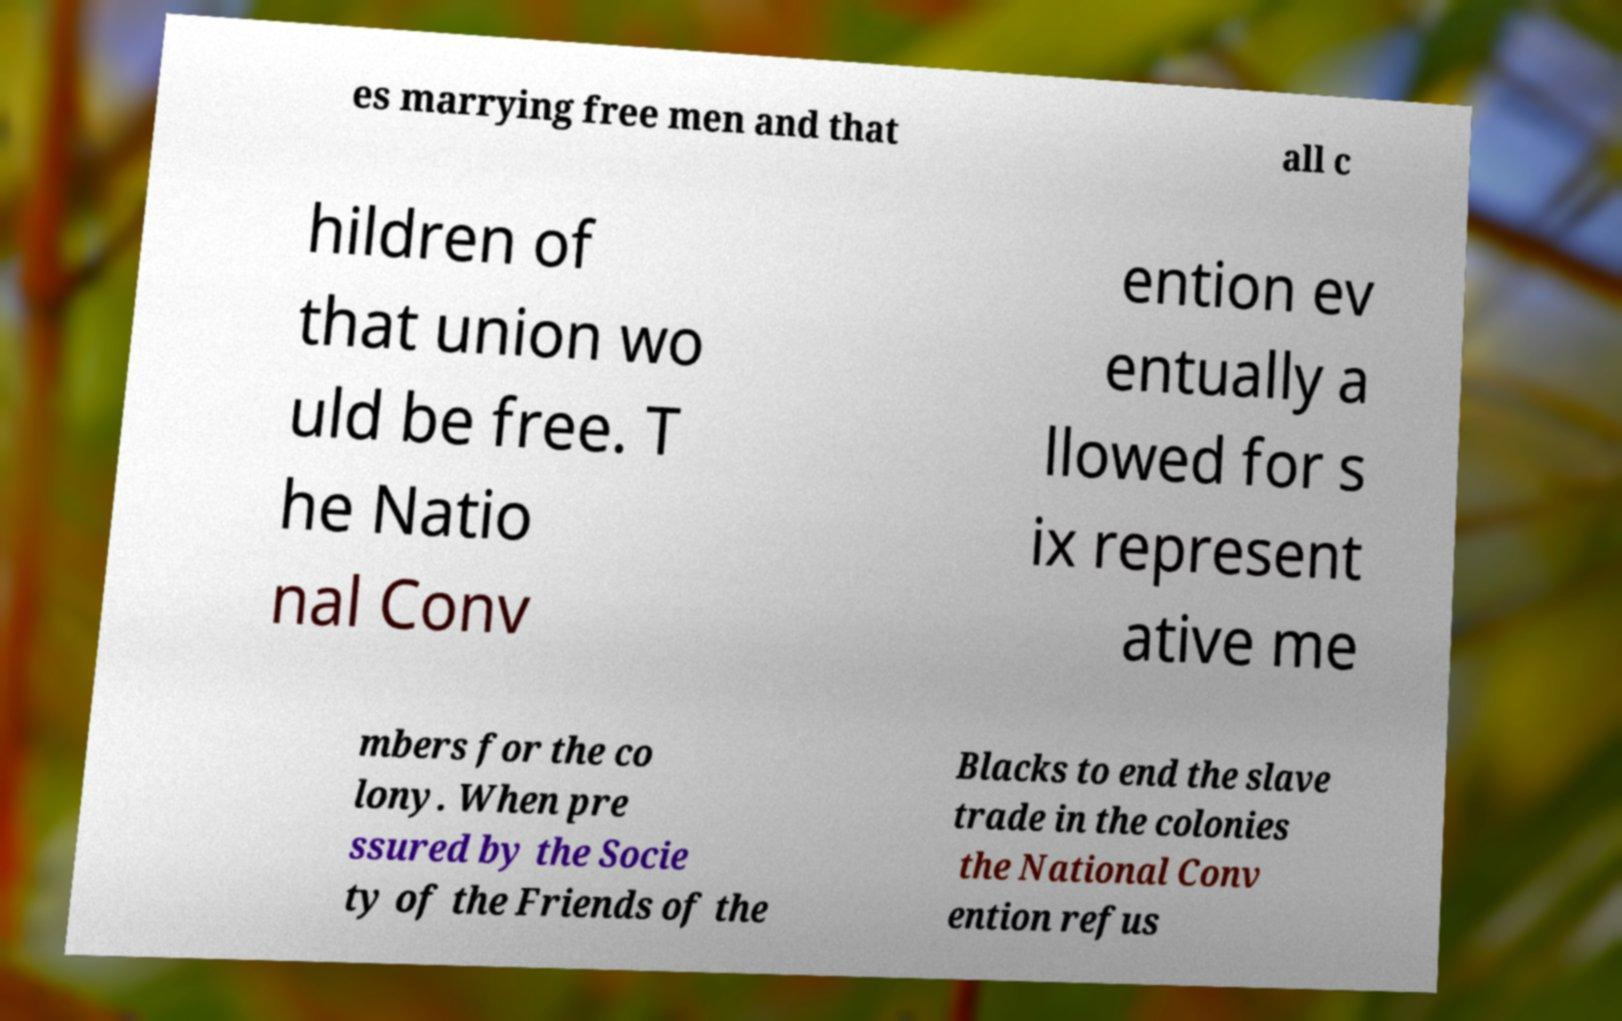What messages or text are displayed in this image? I need them in a readable, typed format. es marrying free men and that all c hildren of that union wo uld be free. T he Natio nal Conv ention ev entually a llowed for s ix represent ative me mbers for the co lony. When pre ssured by the Socie ty of the Friends of the Blacks to end the slave trade in the colonies the National Conv ention refus 